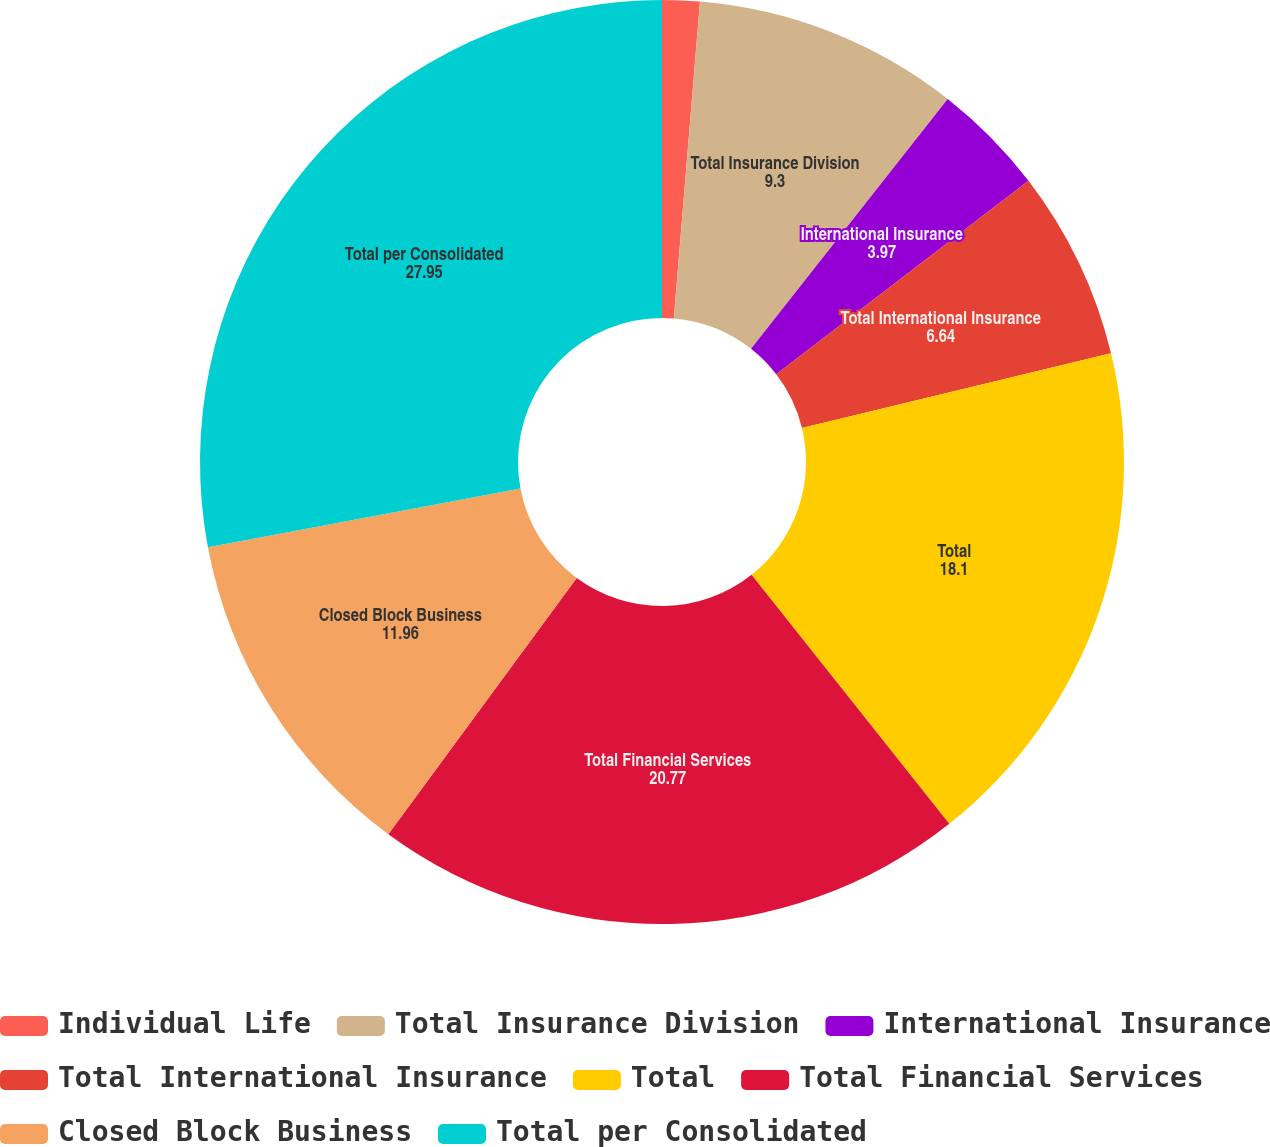Convert chart to OTSL. <chart><loc_0><loc_0><loc_500><loc_500><pie_chart><fcel>Individual Life<fcel>Total Insurance Division<fcel>International Insurance<fcel>Total International Insurance<fcel>Total<fcel>Total Financial Services<fcel>Closed Block Business<fcel>Total per Consolidated<nl><fcel>1.31%<fcel>9.3%<fcel>3.97%<fcel>6.64%<fcel>18.1%<fcel>20.77%<fcel>11.96%<fcel>27.95%<nl></chart> 